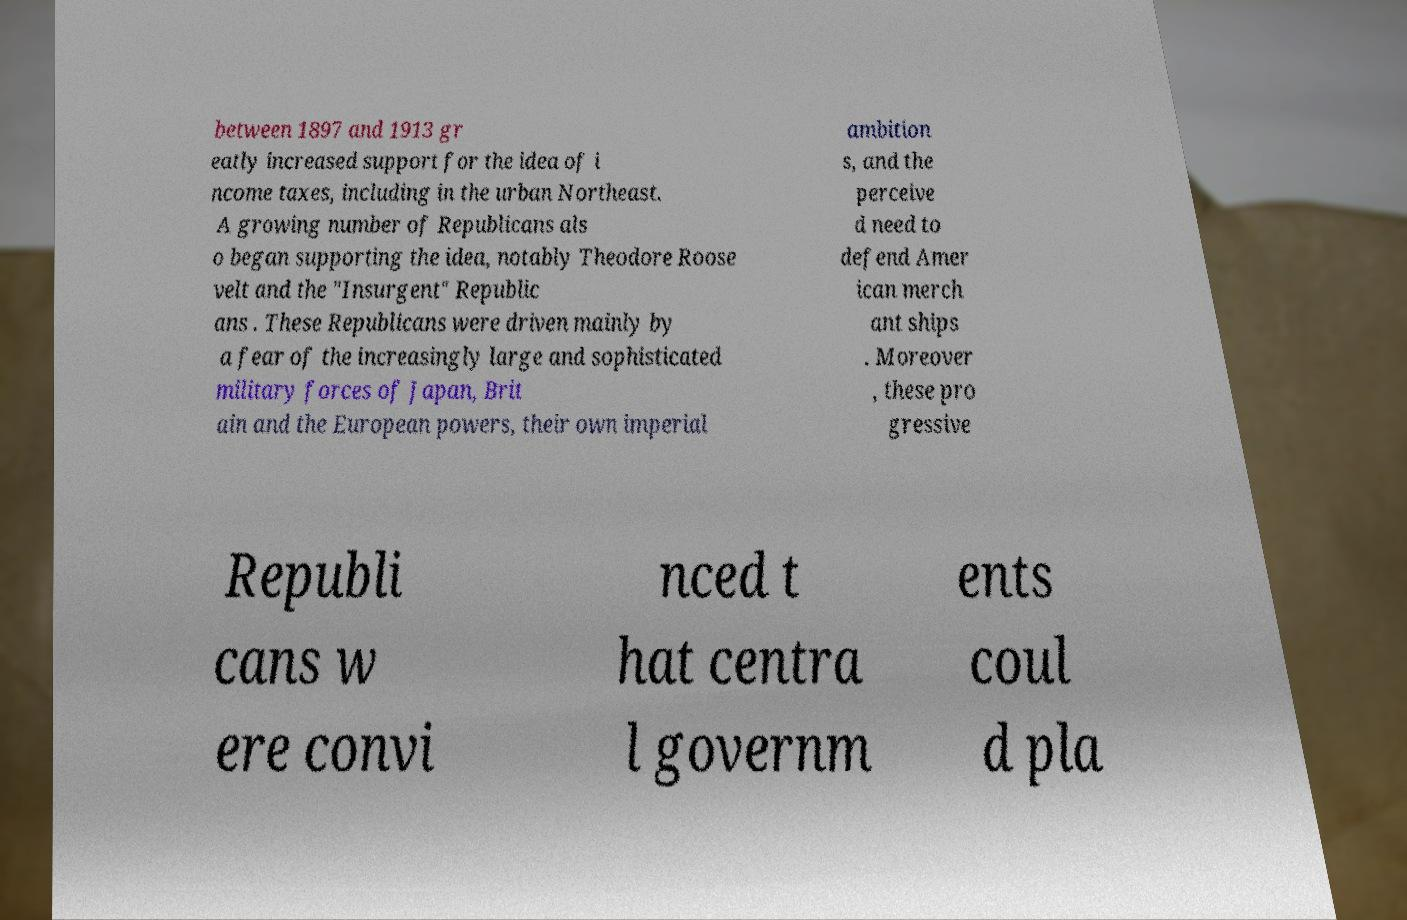There's text embedded in this image that I need extracted. Can you transcribe it verbatim? between 1897 and 1913 gr eatly increased support for the idea of i ncome taxes, including in the urban Northeast. A growing number of Republicans als o began supporting the idea, notably Theodore Roose velt and the "Insurgent" Republic ans . These Republicans were driven mainly by a fear of the increasingly large and sophisticated military forces of Japan, Brit ain and the European powers, their own imperial ambition s, and the perceive d need to defend Amer ican merch ant ships . Moreover , these pro gressive Republi cans w ere convi nced t hat centra l governm ents coul d pla 